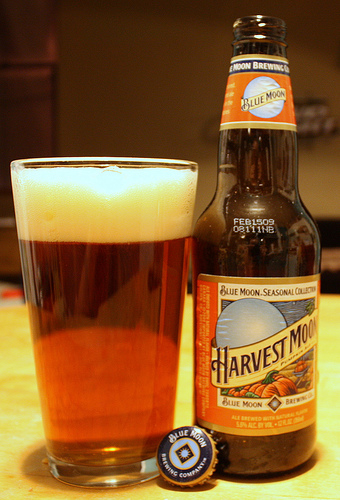<image>
Is there a beer next to the cup? Yes. The beer is positioned adjacent to the cup, located nearby in the same general area. Is the glass behind the bottle? No. The glass is not behind the bottle. From this viewpoint, the glass appears to be positioned elsewhere in the scene. 